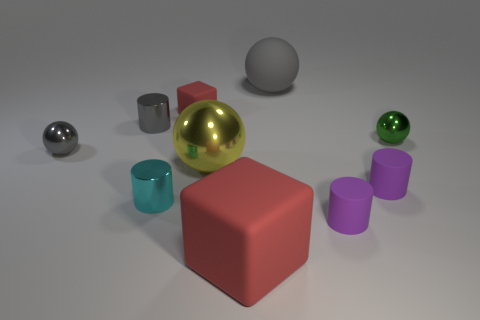There is another ball that is the same color as the matte sphere; what material is it?
Keep it short and to the point. Metal. There is a small shiny sphere to the right of the small cyan cylinder; are there any big red objects behind it?
Your response must be concise. No. What shape is the large thing that is the same material as the large cube?
Your answer should be very brief. Sphere. Is there anything else that has the same color as the big matte ball?
Offer a very short reply. Yes. There is a gray sphere that is in front of the big rubber object that is behind the small red block; what is its material?
Give a very brief answer. Metal. Is there a small green object of the same shape as the yellow object?
Your answer should be very brief. Yes. How many other things are the same shape as the large yellow thing?
Your response must be concise. 3. What shape is the matte thing that is in front of the cyan object and behind the large red matte object?
Offer a terse response. Cylinder. There is a cylinder to the left of the tiny cyan metal object; what is its size?
Provide a short and direct response. Small. Does the cyan cylinder have the same size as the gray shiny cylinder?
Provide a short and direct response. Yes. 